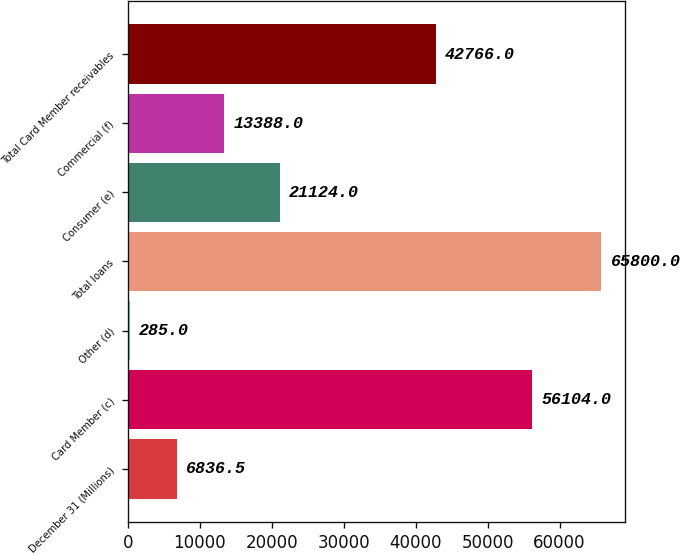Convert chart. <chart><loc_0><loc_0><loc_500><loc_500><bar_chart><fcel>December 31 (Millions)<fcel>Card Member (c)<fcel>Other (d)<fcel>Total loans<fcel>Consumer (e)<fcel>Commercial (f)<fcel>Total Card Member receivables<nl><fcel>6836.5<fcel>56104<fcel>285<fcel>65800<fcel>21124<fcel>13388<fcel>42766<nl></chart> 